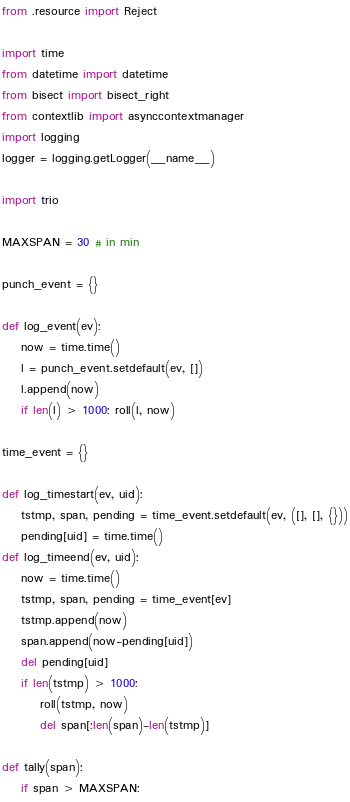<code> <loc_0><loc_0><loc_500><loc_500><_Python_>from .resource import Reject

import time
from datetime import datetime
from bisect import bisect_right
from contextlib import asynccontextmanager
import logging
logger = logging.getLogger(__name__)

import trio

MAXSPAN = 30 # in min

punch_event = {}

def log_event(ev):
    now = time.time()
    l = punch_event.setdefault(ev, [])
    l.append(now)
    if len(l) > 1000: roll(l, now)

time_event = {}

def log_timestart(ev, uid):
    tstmp, span, pending = time_event.setdefault(ev, ([], [], {}))
    pending[uid] = time.time()
def log_timeend(ev, uid):
    now = time.time()
    tstmp, span, pending = time_event[ev]
    tstmp.append(now)
    span.append(now-pending[uid])
    del pending[uid]
    if len(tstmp) > 1000:
        roll(tstmp, now)
        del span[:len(span)-len(tstmp)]

def tally(span):
    if span > MAXSPAN:</code> 